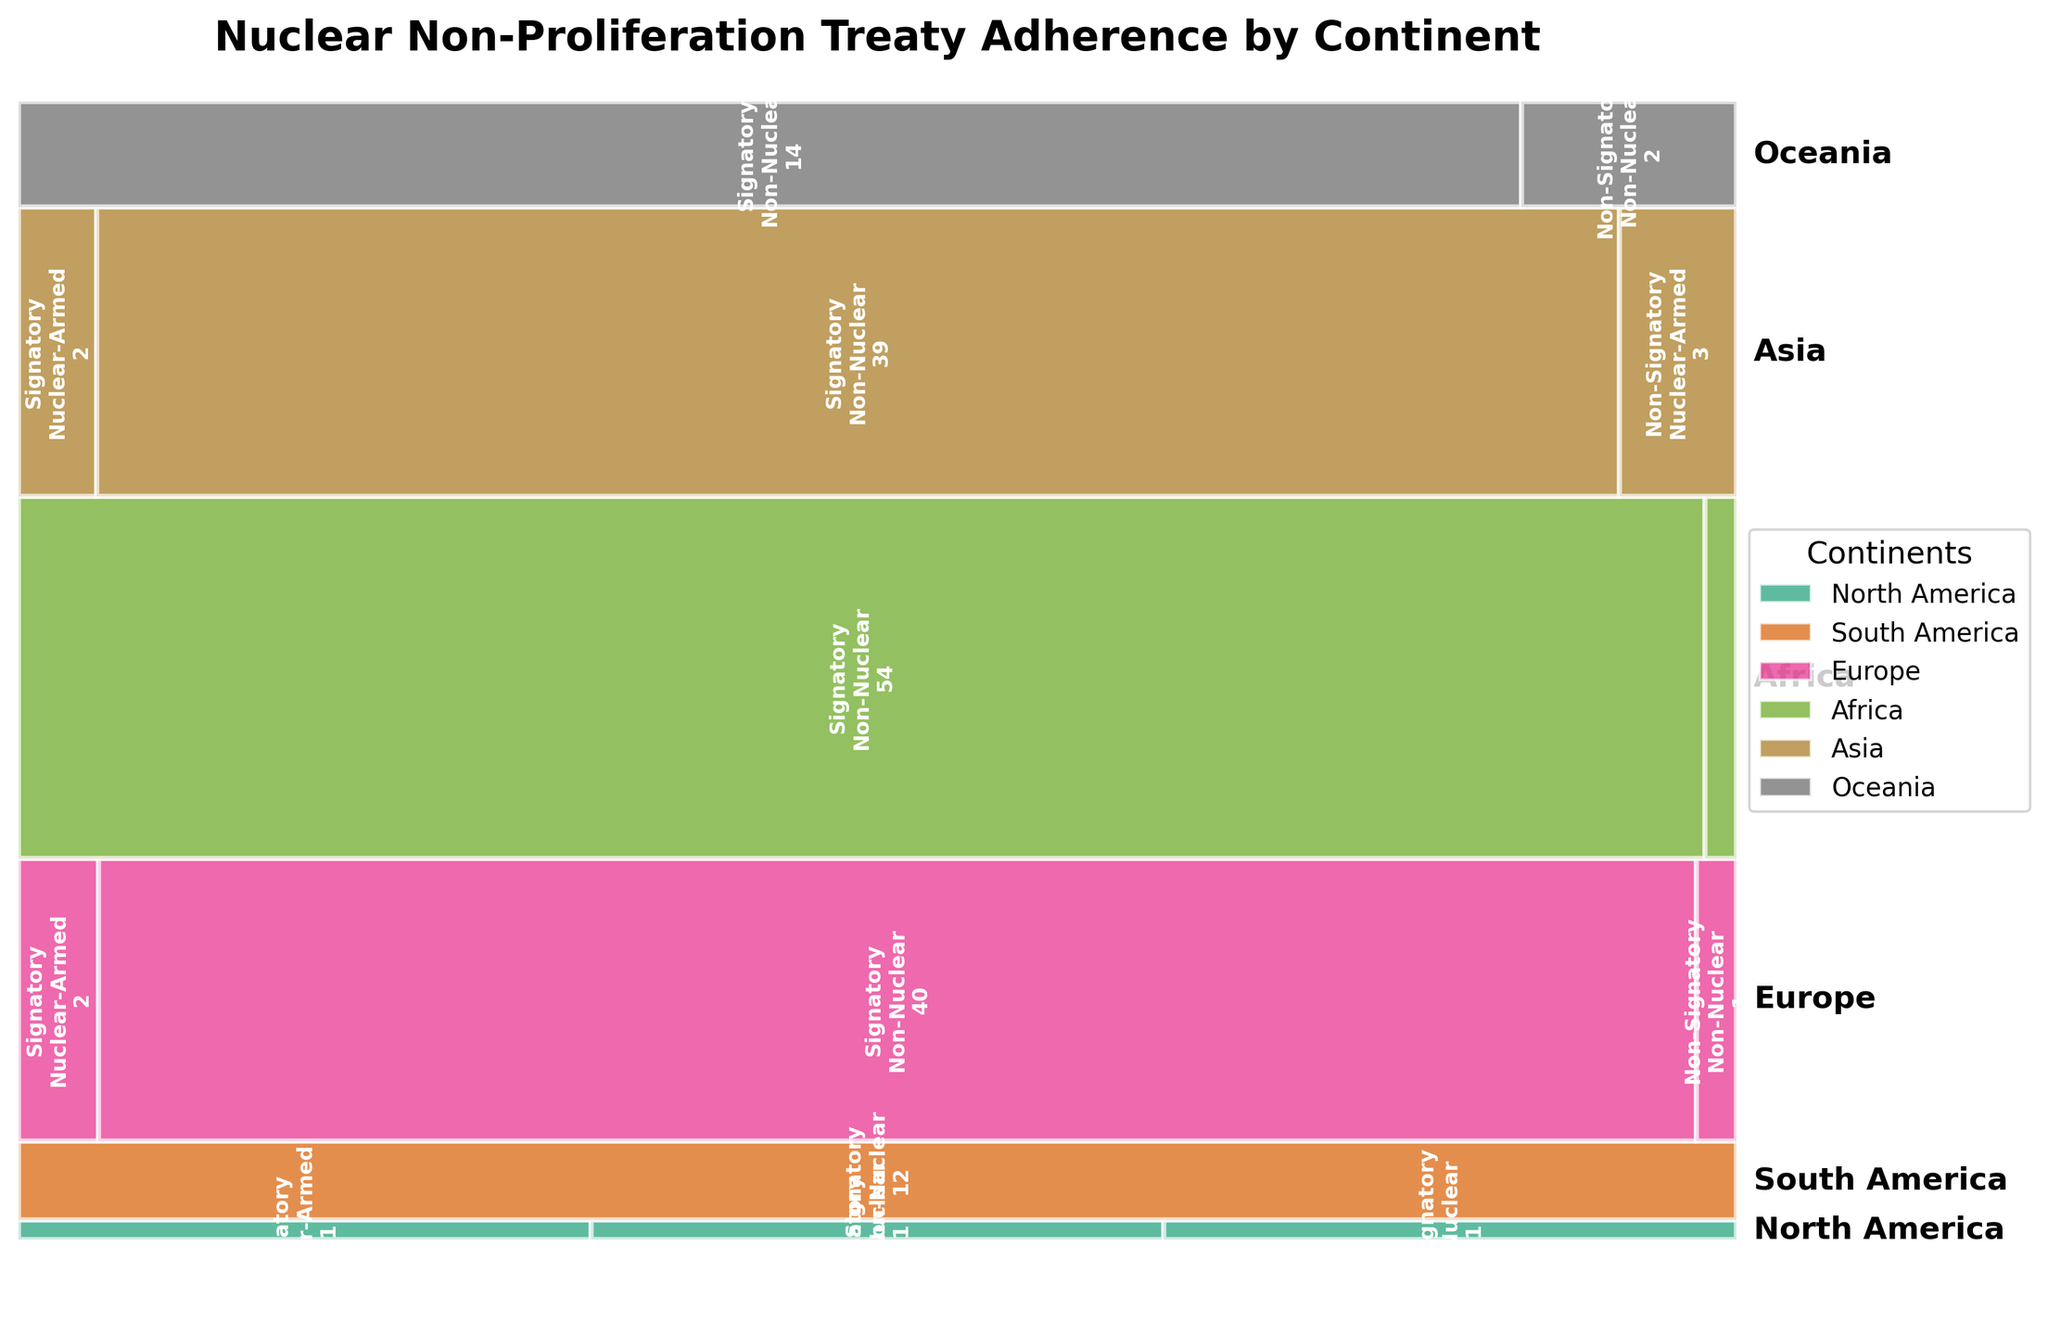What is the title of the mosaic plot? The title is located at the top of the figure and provides a summary of the plot’s content.
Answer: Nuclear Non-Proliferation Treaty Adherence by Continent Which continent has the highest number of non-signatory countries? By looking at the different colored sections labeled "Non-Signatory" in the mosaic plot, we can see which continent has the largest section for non-signatories.
Answer: Asia How many nuclear-armed countries in total are signatories to the treaty? Adding the values given for nuclear-armed signatories in different sections of the plot: North America (1), Europe (2), Asia (2). 1 + 2 + 2 = 5.
Answer: 5 Which continent has the largest proportion of non-nuclear signatories? By comparing the heights of the sections labeled "Signatory" and "Non-Nuclear" within each continent's area, we can determine the largest proportion.
Answer: Africa How many countries in Europe are non-signatories to the treaty? By looking at the section for Europe and summing the counts for categories labeled "Non-Signatory": Non-Nuclear (1).
Answer: 1 Compare the number of nuclear-armed countries in Asia and Europe. Which continent has more? By comparing the count values for nuclear-armed countries in both Asia and Europe, we see that Asia has 3 (including non-signatories) while Europe has 2.
Answer: Asia What is the proportion of non-nuclear countries in Oceania that are non-signatories? Divide the number of non-nuclear, non-signatory countries in Oceania by the total number of countries in Oceania: 2 (Non-Nuclear, Non-Signatory) / (14 + 2 = 16 total) = 2/16 = 12.5%.
Answer: 12.5% Which continent has no nuclear-armed countries, whether signatories or non-signatories? By checking each continent's sections, we identify that South America and Africa have no nuclear-armed countries. Both are non-nuclear, but the correct answer for this question asks for continent only: Africa.
Answer: Africa Compare the number of signatories in North America and Oceania. Which continent has more? By comparing the rectangles labeled "Signatory": North America has 2 (Nuclear-Armed + Non-Nuclear) while Oceania has 14 (Non-Nuclear).
Answer: Oceania 